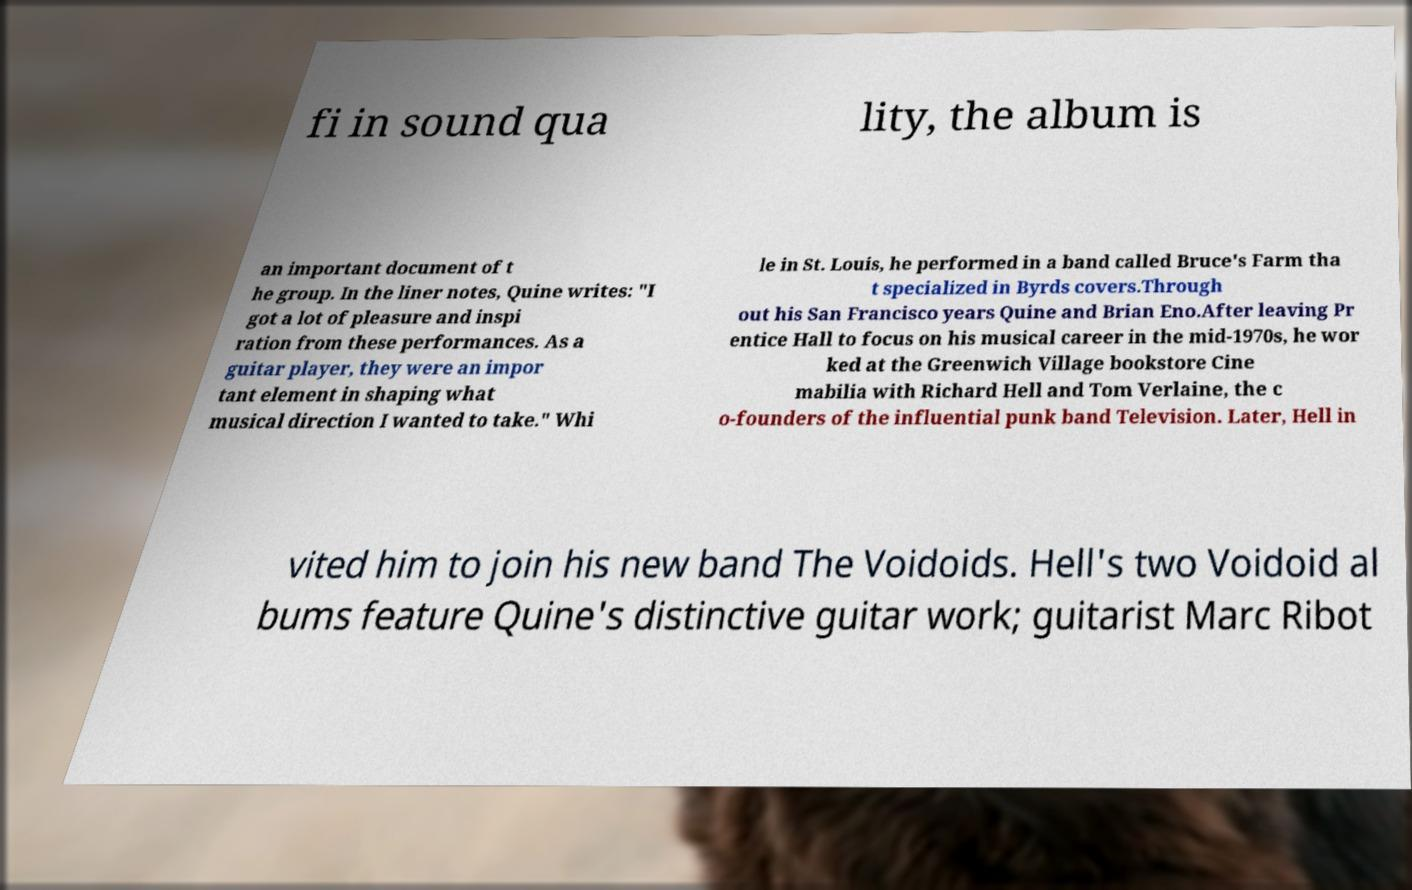There's text embedded in this image that I need extracted. Can you transcribe it verbatim? fi in sound qua lity, the album is an important document of t he group. In the liner notes, Quine writes: "I got a lot of pleasure and inspi ration from these performances. As a guitar player, they were an impor tant element in shaping what musical direction I wanted to take." Whi le in St. Louis, he performed in a band called Bruce's Farm tha t specialized in Byrds covers.Through out his San Francisco years Quine and Brian Eno.After leaving Pr entice Hall to focus on his musical career in the mid-1970s, he wor ked at the Greenwich Village bookstore Cine mabilia with Richard Hell and Tom Verlaine, the c o-founders of the influential punk band Television. Later, Hell in vited him to join his new band The Voidoids. Hell's two Voidoid al bums feature Quine's distinctive guitar work; guitarist Marc Ribot 